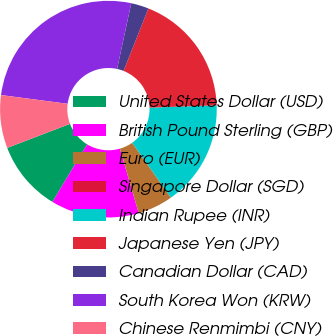Convert chart to OTSL. <chart><loc_0><loc_0><loc_500><loc_500><pie_chart><fcel>United States Dollar (USD)<fcel>British Pound Sterling (GBP)<fcel>Euro (EUR)<fcel>Singapore Dollar (SGD)<fcel>Indian Rupee (INR)<fcel>Japanese Yen (JPY)<fcel>Canadian Dollar (CAD)<fcel>South Korea Won (KRW)<fcel>Chinese Renmimbi (CNY)<nl><fcel>10.53%<fcel>13.16%<fcel>5.27%<fcel>0.01%<fcel>15.78%<fcel>18.41%<fcel>2.64%<fcel>26.3%<fcel>7.9%<nl></chart> 